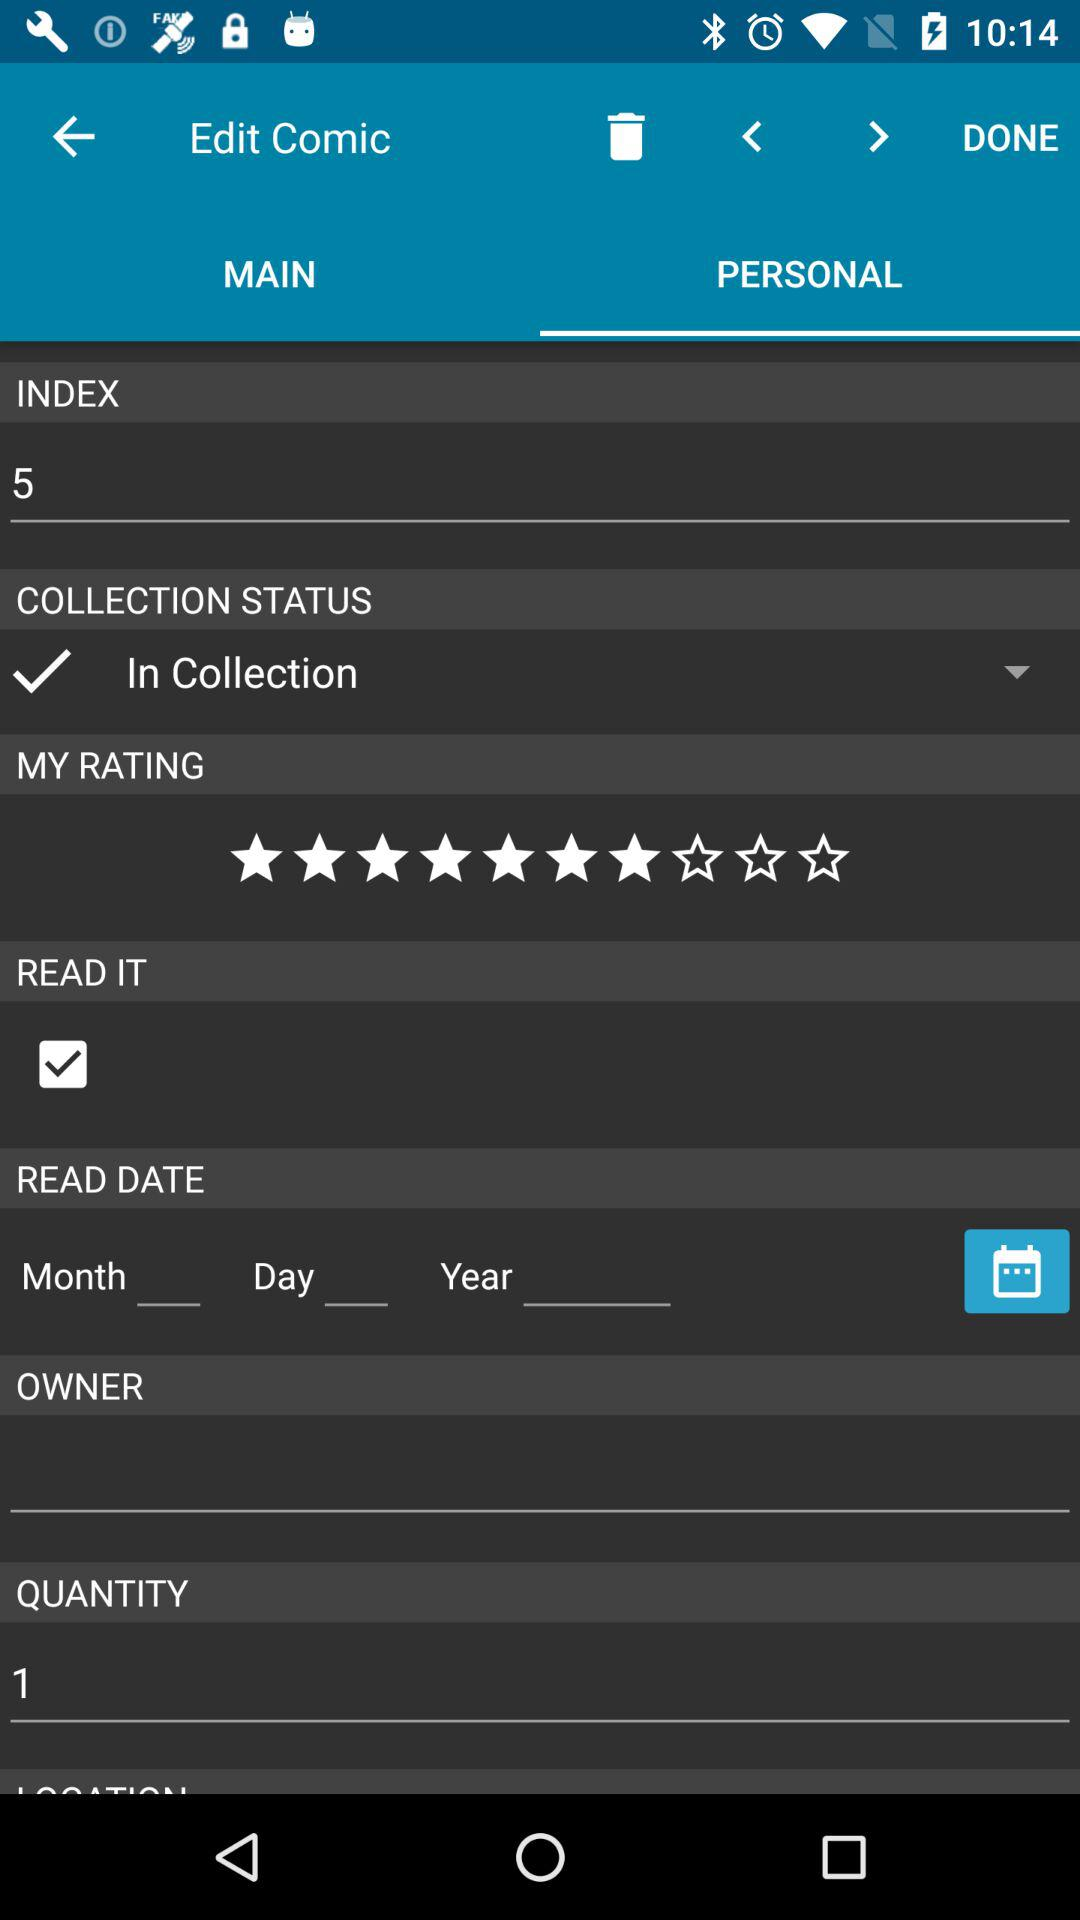What's the status of "READ IT"? The status of "READ IT" is "on". 